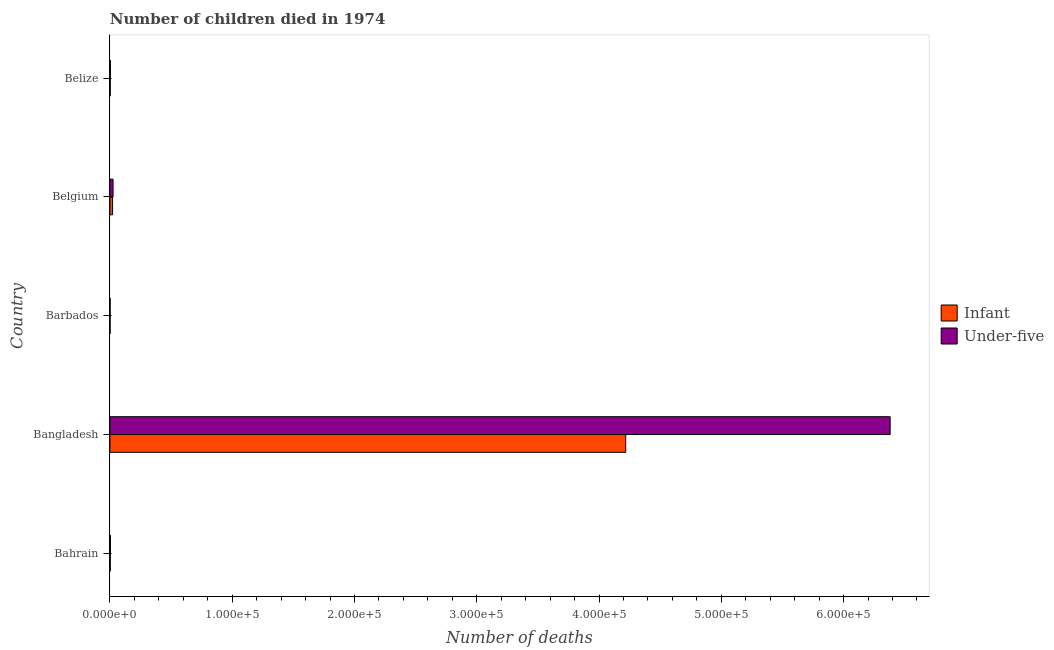How many bars are there on the 4th tick from the top?
Offer a very short reply. 2. How many bars are there on the 2nd tick from the bottom?
Provide a short and direct response. 2. What is the label of the 1st group of bars from the top?
Your answer should be very brief. Belize. In how many cases, is the number of bars for a given country not equal to the number of legend labels?
Your response must be concise. 0. What is the number of infant deaths in Belize?
Provide a succinct answer. 332. Across all countries, what is the maximum number of under-five deaths?
Offer a terse response. 6.38e+05. Across all countries, what is the minimum number of under-five deaths?
Your answer should be very brief. 187. In which country was the number of under-five deaths maximum?
Ensure brevity in your answer.  Bangladesh. In which country was the number of under-five deaths minimum?
Your answer should be compact. Barbados. What is the total number of infant deaths in the graph?
Keep it short and to the point. 4.25e+05. What is the difference between the number of under-five deaths in Barbados and that in Belize?
Offer a very short reply. -255. What is the difference between the number of under-five deaths in Bangladesh and the number of infant deaths in Barbados?
Your response must be concise. 6.38e+05. What is the average number of infant deaths per country?
Make the answer very short. 8.50e+04. What is the difference between the number of infant deaths and number of under-five deaths in Barbados?
Make the answer very short. -24. In how many countries, is the number of infant deaths greater than 240000 ?
Keep it short and to the point. 1. What is the ratio of the number of under-five deaths in Bangladesh to that in Belize?
Your answer should be compact. 1443.65. What is the difference between the highest and the second highest number of infant deaths?
Provide a succinct answer. 4.20e+05. What is the difference between the highest and the lowest number of under-five deaths?
Your answer should be very brief. 6.38e+05. In how many countries, is the number of infant deaths greater than the average number of infant deaths taken over all countries?
Ensure brevity in your answer.  1. What does the 2nd bar from the top in Belize represents?
Your answer should be compact. Infant. What does the 2nd bar from the bottom in Bahrain represents?
Your response must be concise. Under-five. Are all the bars in the graph horizontal?
Your answer should be compact. Yes. How many countries are there in the graph?
Offer a terse response. 5. Are the values on the major ticks of X-axis written in scientific E-notation?
Make the answer very short. Yes. Does the graph contain any zero values?
Offer a terse response. No. Where does the legend appear in the graph?
Offer a very short reply. Center right. How are the legend labels stacked?
Your answer should be compact. Vertical. What is the title of the graph?
Keep it short and to the point. Number of children died in 1974. Does "Fraud firms" appear as one of the legend labels in the graph?
Keep it short and to the point. No. What is the label or title of the X-axis?
Your answer should be compact. Number of deaths. What is the label or title of the Y-axis?
Make the answer very short. Country. What is the Number of deaths of Infant in Bahrain?
Offer a very short reply. 333. What is the Number of deaths of Under-five in Bahrain?
Keep it short and to the point. 421. What is the Number of deaths in Infant in Bangladesh?
Provide a short and direct response. 4.22e+05. What is the Number of deaths in Under-five in Bangladesh?
Your answer should be very brief. 6.38e+05. What is the Number of deaths of Infant in Barbados?
Your answer should be very brief. 163. What is the Number of deaths in Under-five in Barbados?
Give a very brief answer. 187. What is the Number of deaths in Infant in Belgium?
Make the answer very short. 2201. What is the Number of deaths in Under-five in Belgium?
Provide a short and direct response. 2592. What is the Number of deaths of Infant in Belize?
Give a very brief answer. 332. What is the Number of deaths of Under-five in Belize?
Ensure brevity in your answer.  442. Across all countries, what is the maximum Number of deaths of Infant?
Your answer should be compact. 4.22e+05. Across all countries, what is the maximum Number of deaths of Under-five?
Provide a succinct answer. 6.38e+05. Across all countries, what is the minimum Number of deaths in Infant?
Ensure brevity in your answer.  163. Across all countries, what is the minimum Number of deaths in Under-five?
Give a very brief answer. 187. What is the total Number of deaths in Infant in the graph?
Give a very brief answer. 4.25e+05. What is the total Number of deaths in Under-five in the graph?
Give a very brief answer. 6.42e+05. What is the difference between the Number of deaths of Infant in Bahrain and that in Bangladesh?
Offer a terse response. -4.21e+05. What is the difference between the Number of deaths of Under-five in Bahrain and that in Bangladesh?
Offer a very short reply. -6.38e+05. What is the difference between the Number of deaths of Infant in Bahrain and that in Barbados?
Ensure brevity in your answer.  170. What is the difference between the Number of deaths in Under-five in Bahrain and that in Barbados?
Give a very brief answer. 234. What is the difference between the Number of deaths of Infant in Bahrain and that in Belgium?
Give a very brief answer. -1868. What is the difference between the Number of deaths of Under-five in Bahrain and that in Belgium?
Keep it short and to the point. -2171. What is the difference between the Number of deaths in Under-five in Bahrain and that in Belize?
Provide a succinct answer. -21. What is the difference between the Number of deaths of Infant in Bangladesh and that in Barbados?
Make the answer very short. 4.22e+05. What is the difference between the Number of deaths in Under-five in Bangladesh and that in Barbados?
Your response must be concise. 6.38e+05. What is the difference between the Number of deaths of Infant in Bangladesh and that in Belgium?
Your response must be concise. 4.20e+05. What is the difference between the Number of deaths in Under-five in Bangladesh and that in Belgium?
Provide a succinct answer. 6.36e+05. What is the difference between the Number of deaths of Infant in Bangladesh and that in Belize?
Your response must be concise. 4.21e+05. What is the difference between the Number of deaths in Under-five in Bangladesh and that in Belize?
Offer a terse response. 6.38e+05. What is the difference between the Number of deaths of Infant in Barbados and that in Belgium?
Make the answer very short. -2038. What is the difference between the Number of deaths of Under-five in Barbados and that in Belgium?
Keep it short and to the point. -2405. What is the difference between the Number of deaths of Infant in Barbados and that in Belize?
Your answer should be very brief. -169. What is the difference between the Number of deaths in Under-five in Barbados and that in Belize?
Your answer should be compact. -255. What is the difference between the Number of deaths in Infant in Belgium and that in Belize?
Provide a short and direct response. 1869. What is the difference between the Number of deaths in Under-five in Belgium and that in Belize?
Your response must be concise. 2150. What is the difference between the Number of deaths of Infant in Bahrain and the Number of deaths of Under-five in Bangladesh?
Ensure brevity in your answer.  -6.38e+05. What is the difference between the Number of deaths of Infant in Bahrain and the Number of deaths of Under-five in Barbados?
Ensure brevity in your answer.  146. What is the difference between the Number of deaths of Infant in Bahrain and the Number of deaths of Under-five in Belgium?
Offer a very short reply. -2259. What is the difference between the Number of deaths of Infant in Bahrain and the Number of deaths of Under-five in Belize?
Make the answer very short. -109. What is the difference between the Number of deaths in Infant in Bangladesh and the Number of deaths in Under-five in Barbados?
Make the answer very short. 4.22e+05. What is the difference between the Number of deaths in Infant in Bangladesh and the Number of deaths in Under-five in Belgium?
Your answer should be very brief. 4.19e+05. What is the difference between the Number of deaths of Infant in Bangladesh and the Number of deaths of Under-five in Belize?
Make the answer very short. 4.21e+05. What is the difference between the Number of deaths of Infant in Barbados and the Number of deaths of Under-five in Belgium?
Your answer should be compact. -2429. What is the difference between the Number of deaths in Infant in Barbados and the Number of deaths in Under-five in Belize?
Keep it short and to the point. -279. What is the difference between the Number of deaths in Infant in Belgium and the Number of deaths in Under-five in Belize?
Your answer should be very brief. 1759. What is the average Number of deaths in Infant per country?
Your answer should be very brief. 8.50e+04. What is the average Number of deaths in Under-five per country?
Your answer should be very brief. 1.28e+05. What is the difference between the Number of deaths of Infant and Number of deaths of Under-five in Bahrain?
Ensure brevity in your answer.  -88. What is the difference between the Number of deaths of Infant and Number of deaths of Under-five in Bangladesh?
Make the answer very short. -2.16e+05. What is the difference between the Number of deaths in Infant and Number of deaths in Under-five in Barbados?
Your answer should be compact. -24. What is the difference between the Number of deaths in Infant and Number of deaths in Under-five in Belgium?
Offer a terse response. -391. What is the difference between the Number of deaths of Infant and Number of deaths of Under-five in Belize?
Provide a succinct answer. -110. What is the ratio of the Number of deaths in Infant in Bahrain to that in Bangladesh?
Ensure brevity in your answer.  0. What is the ratio of the Number of deaths in Under-five in Bahrain to that in Bangladesh?
Your answer should be compact. 0. What is the ratio of the Number of deaths in Infant in Bahrain to that in Barbados?
Provide a succinct answer. 2.04. What is the ratio of the Number of deaths in Under-five in Bahrain to that in Barbados?
Offer a terse response. 2.25. What is the ratio of the Number of deaths of Infant in Bahrain to that in Belgium?
Your response must be concise. 0.15. What is the ratio of the Number of deaths in Under-five in Bahrain to that in Belgium?
Provide a succinct answer. 0.16. What is the ratio of the Number of deaths in Infant in Bahrain to that in Belize?
Your response must be concise. 1. What is the ratio of the Number of deaths in Under-five in Bahrain to that in Belize?
Ensure brevity in your answer.  0.95. What is the ratio of the Number of deaths in Infant in Bangladesh to that in Barbados?
Offer a terse response. 2587.88. What is the ratio of the Number of deaths of Under-five in Bangladesh to that in Barbados?
Your answer should be compact. 3412.26. What is the ratio of the Number of deaths in Infant in Bangladesh to that in Belgium?
Provide a short and direct response. 191.65. What is the ratio of the Number of deaths in Under-five in Bangladesh to that in Belgium?
Your answer should be very brief. 246.18. What is the ratio of the Number of deaths of Infant in Bangladesh to that in Belize?
Your answer should be compact. 1270.55. What is the ratio of the Number of deaths in Under-five in Bangladesh to that in Belize?
Provide a succinct answer. 1443.65. What is the ratio of the Number of deaths in Infant in Barbados to that in Belgium?
Your answer should be compact. 0.07. What is the ratio of the Number of deaths of Under-five in Barbados to that in Belgium?
Provide a short and direct response. 0.07. What is the ratio of the Number of deaths of Infant in Barbados to that in Belize?
Offer a terse response. 0.49. What is the ratio of the Number of deaths in Under-five in Barbados to that in Belize?
Keep it short and to the point. 0.42. What is the ratio of the Number of deaths of Infant in Belgium to that in Belize?
Offer a terse response. 6.63. What is the ratio of the Number of deaths in Under-five in Belgium to that in Belize?
Your response must be concise. 5.86. What is the difference between the highest and the second highest Number of deaths in Infant?
Ensure brevity in your answer.  4.20e+05. What is the difference between the highest and the second highest Number of deaths of Under-five?
Offer a very short reply. 6.36e+05. What is the difference between the highest and the lowest Number of deaths of Infant?
Offer a very short reply. 4.22e+05. What is the difference between the highest and the lowest Number of deaths of Under-five?
Offer a very short reply. 6.38e+05. 